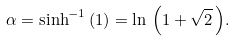<formula> <loc_0><loc_0><loc_500><loc_500>\alpha = \sinh ^ { - 1 } { ( 1 ) } = \ln \, { \left ( 1 + \sqrt { 2 } \, \right ) } .</formula> 